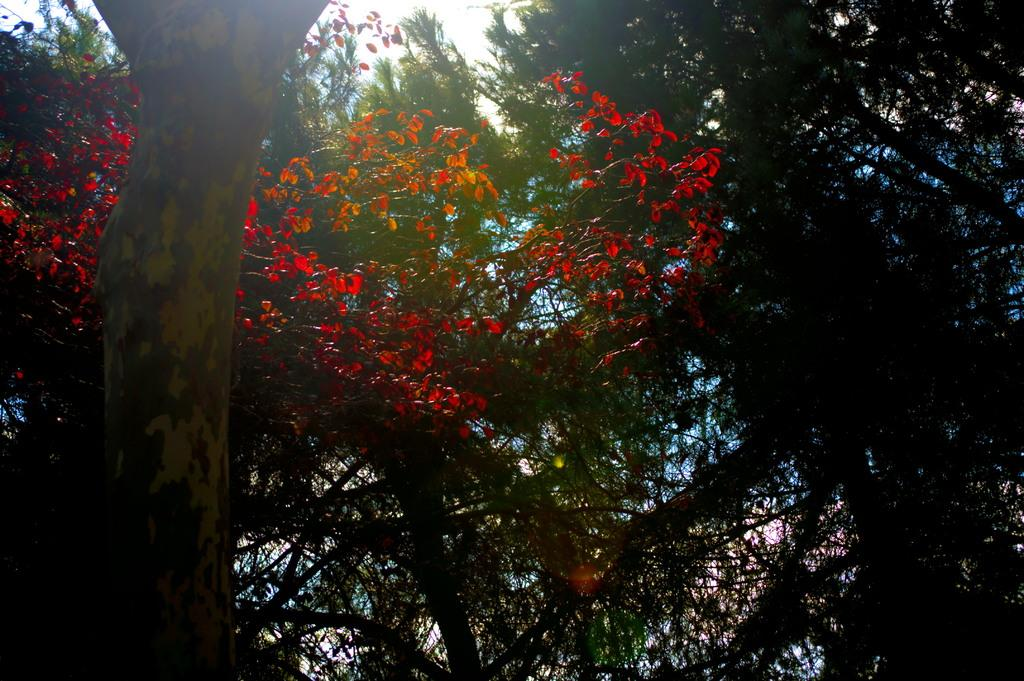What type of vegetation can be seen in the image? There are a few trees in the image. What part of the natural environment is visible in the image? The sky is visible in the image. What type of pain is the person in the image experiencing? There is no person present in the image, so it is not possible to determine if they are experiencing any pain. What type of stocking is the person in the image wearing? There is no person present in the image, so it is not possible to determine if they are wearing any stockings. 